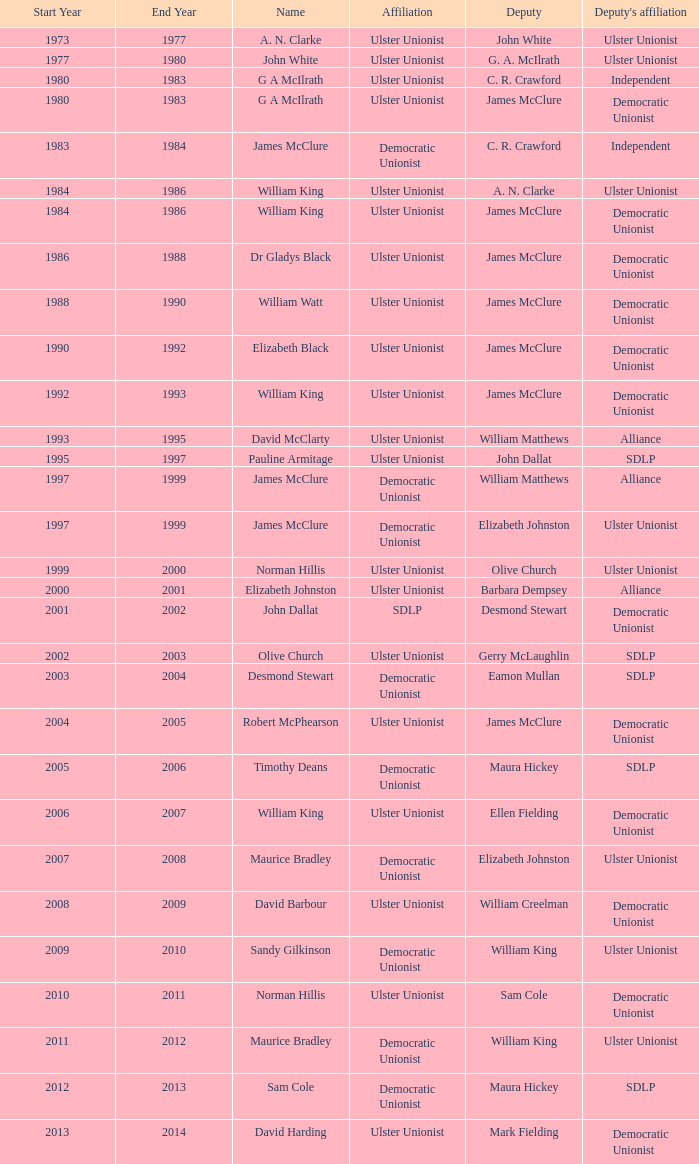What is the Deputy's affiliation in 1992–93? Democratic Unionist. 